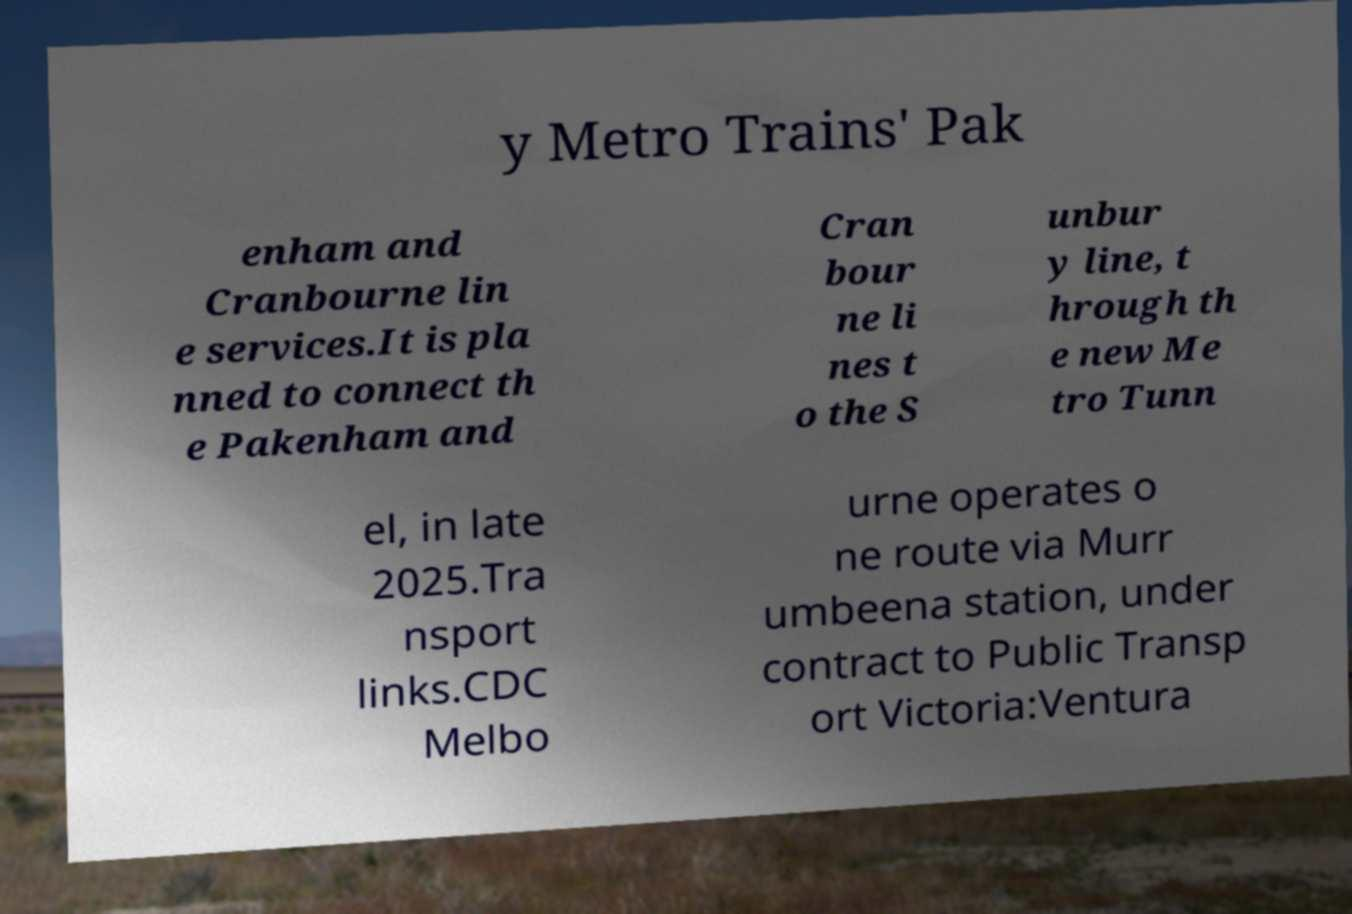Could you assist in decoding the text presented in this image and type it out clearly? y Metro Trains' Pak enham and Cranbourne lin e services.It is pla nned to connect th e Pakenham and Cran bour ne li nes t o the S unbur y line, t hrough th e new Me tro Tunn el, in late 2025.Tra nsport links.CDC Melbo urne operates o ne route via Murr umbeena station, under contract to Public Transp ort Victoria:Ventura 